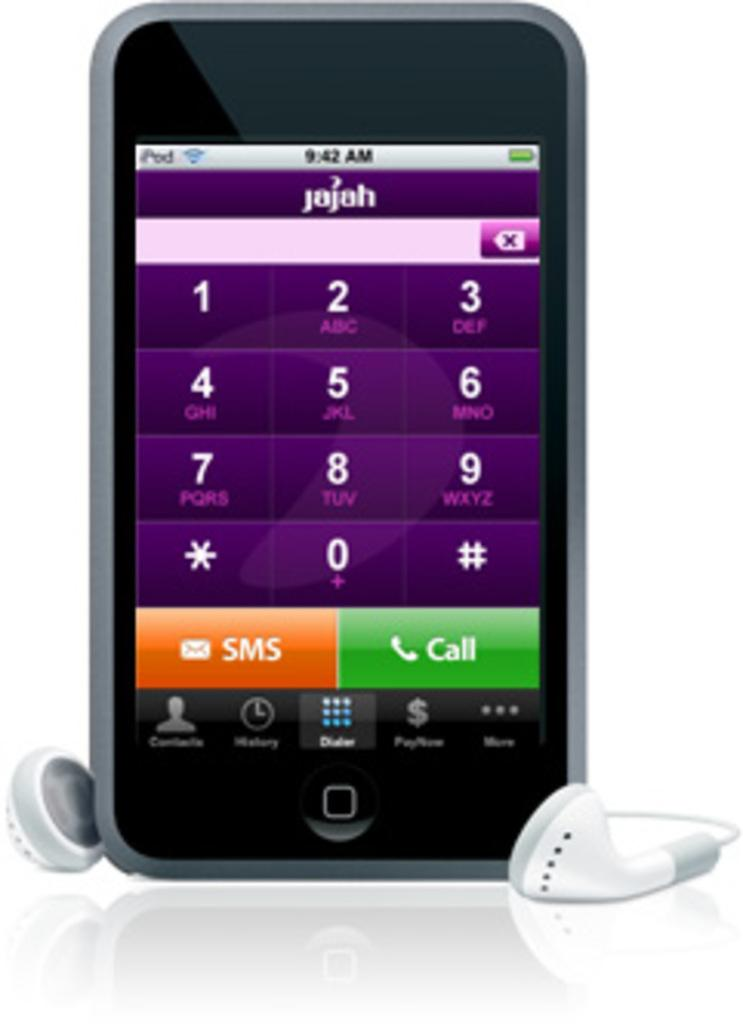<image>
Create a compact narrative representing the image presented. Phone screen showing a Call button in green and SMS button in orange. 